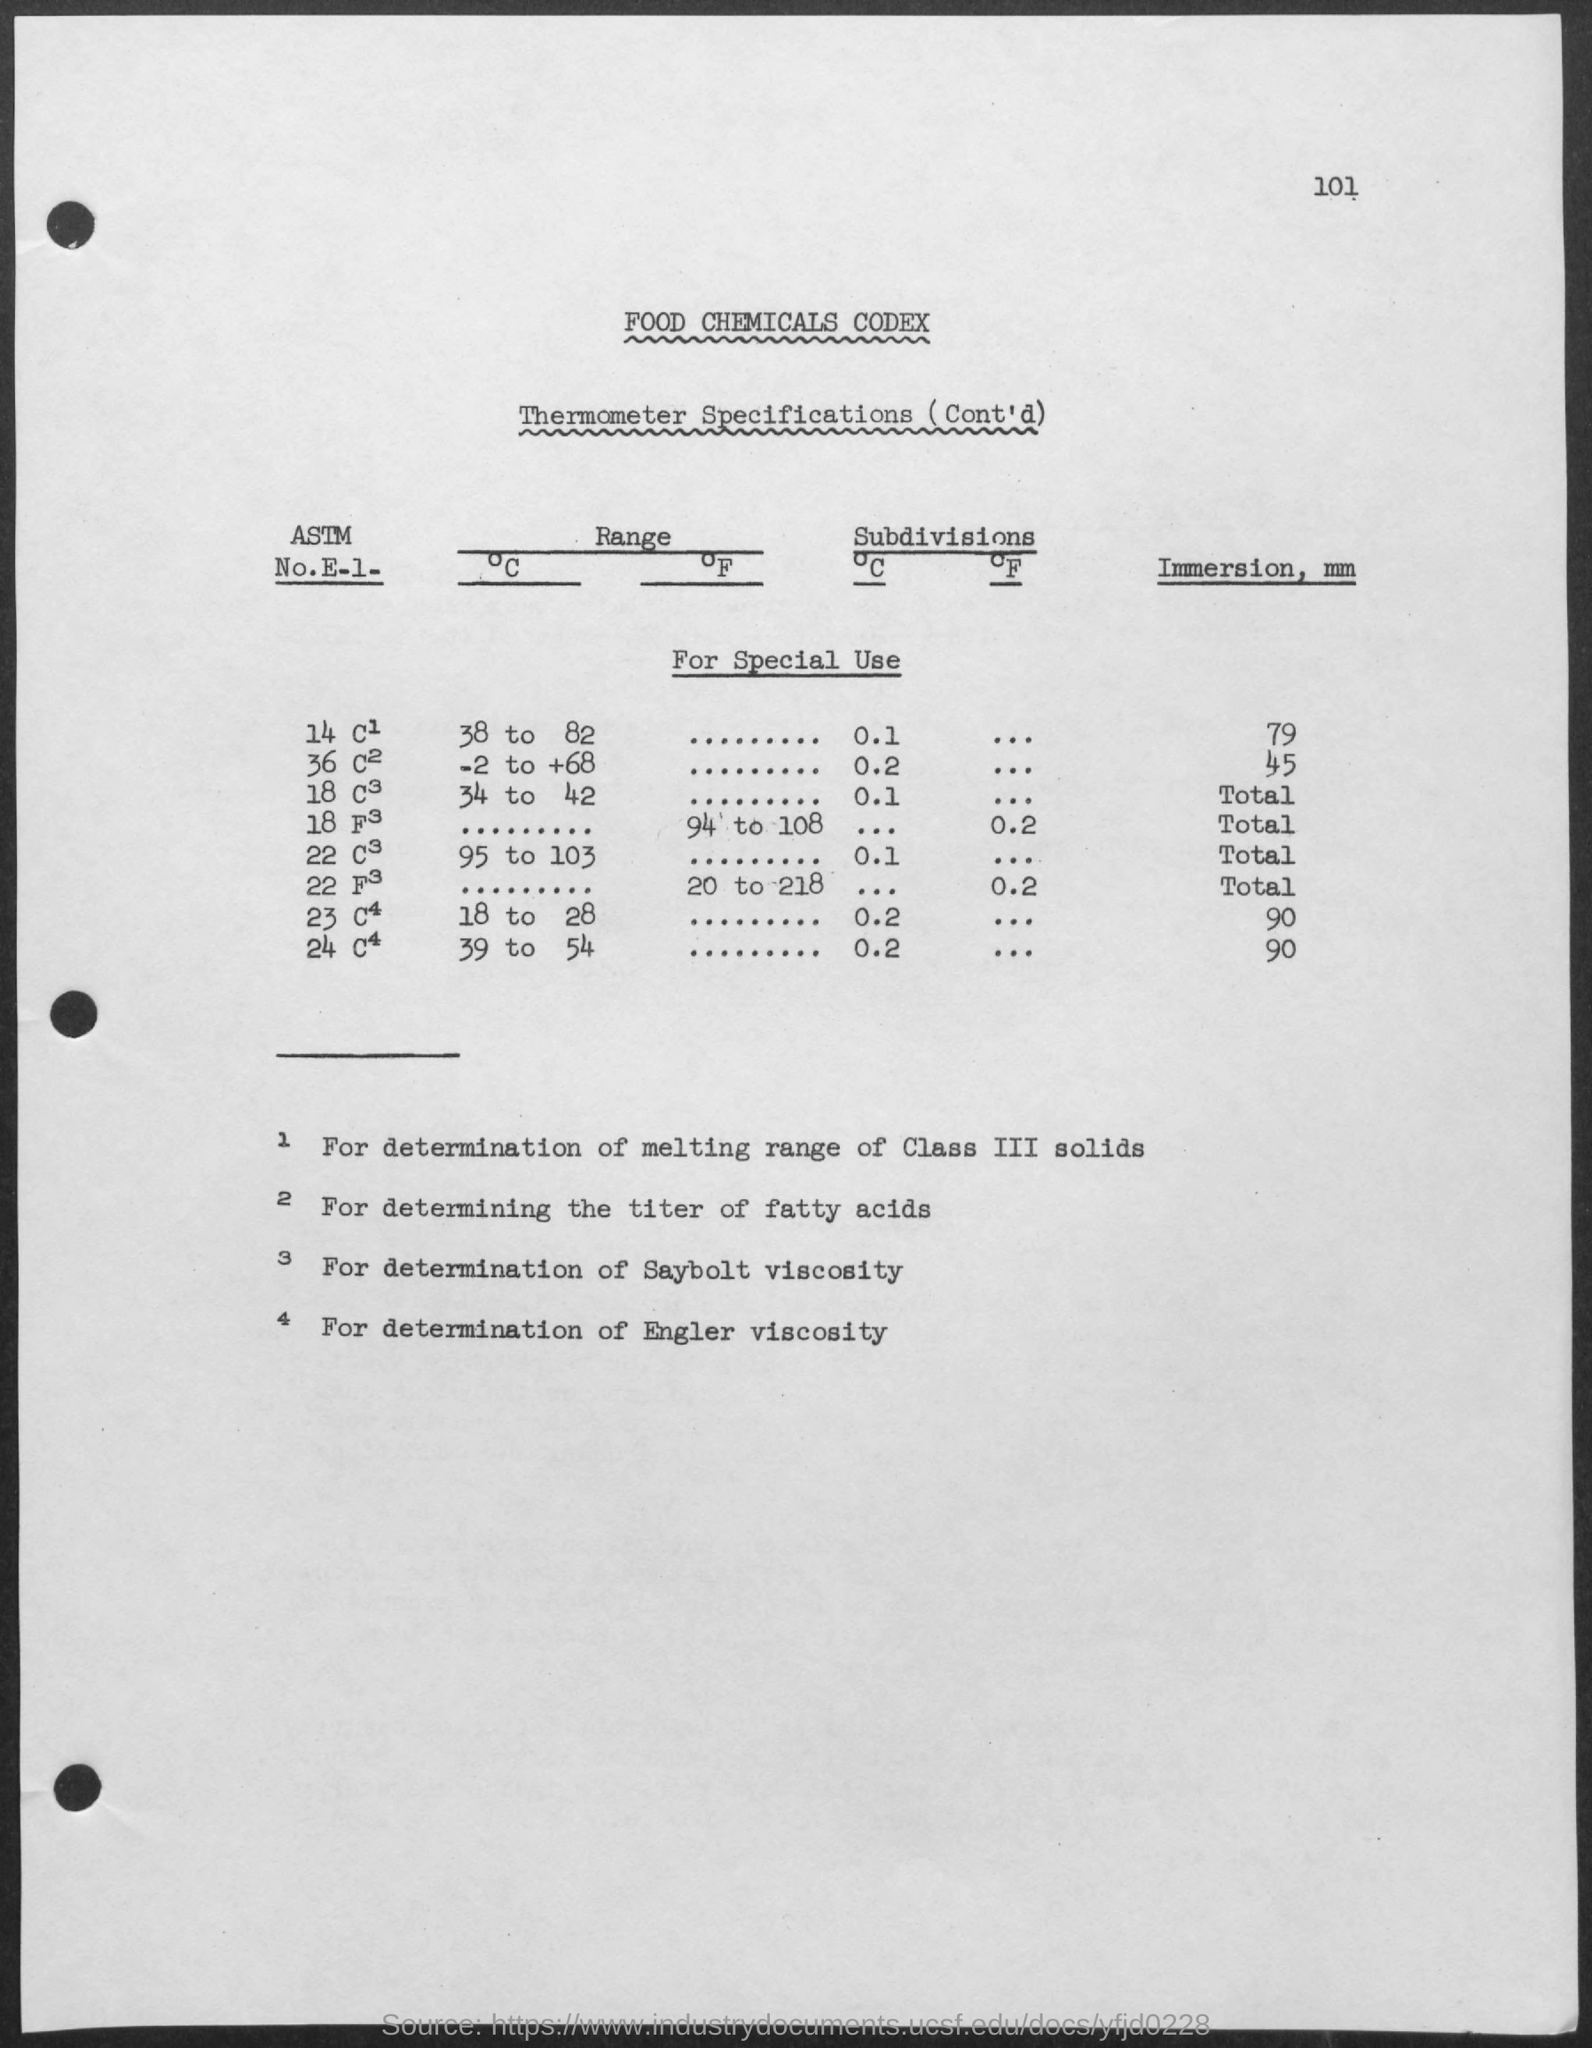What is the page number?
Your answer should be very brief. 101. What is the first title in the document?
Give a very brief answer. Food Chemicals Codex. What is the second title in the document?
Your answer should be very brief. Thermometer Specifications (Cont'd). 